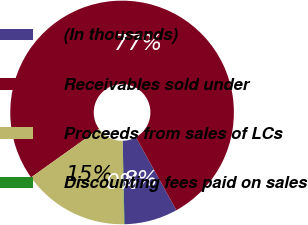<chart> <loc_0><loc_0><loc_500><loc_500><pie_chart><fcel>(In thousands)<fcel>Receivables sold under<fcel>Proceeds from sales of LCs<fcel>Discounting fees paid on sales<nl><fcel>7.73%<fcel>76.8%<fcel>15.41%<fcel>0.06%<nl></chart> 